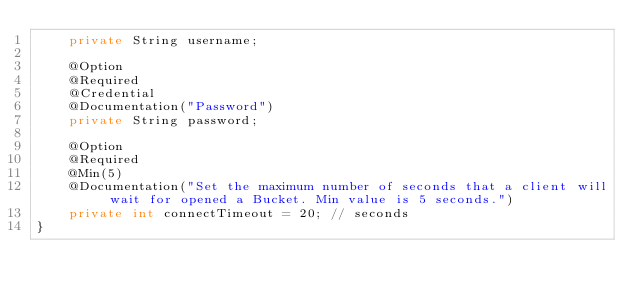<code> <loc_0><loc_0><loc_500><loc_500><_Java_>    private String username;

    @Option
    @Required
    @Credential
    @Documentation("Password")
    private String password;

    @Option
    @Required
    @Min(5)
    @Documentation("Set the maximum number of seconds that a client will wait for opened a Bucket. Min value is 5 seconds.")
    private int connectTimeout = 20; // seconds
}</code> 